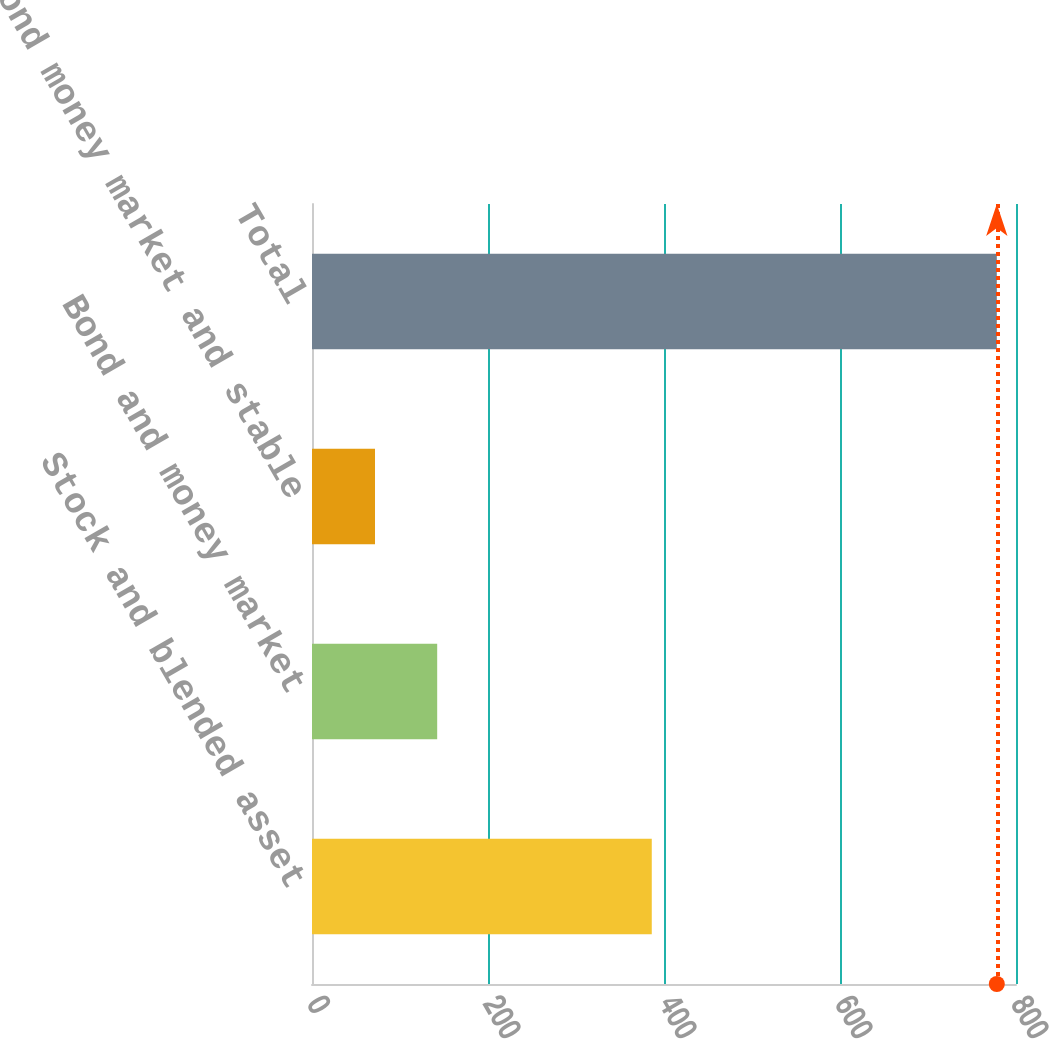Convert chart to OTSL. <chart><loc_0><loc_0><loc_500><loc_500><bar_chart><fcel>Stock and blended asset<fcel>Bond and money market<fcel>Bond money market and stable<fcel>Total<nl><fcel>386.1<fcel>142.26<fcel>71.6<fcel>778.2<nl></chart> 